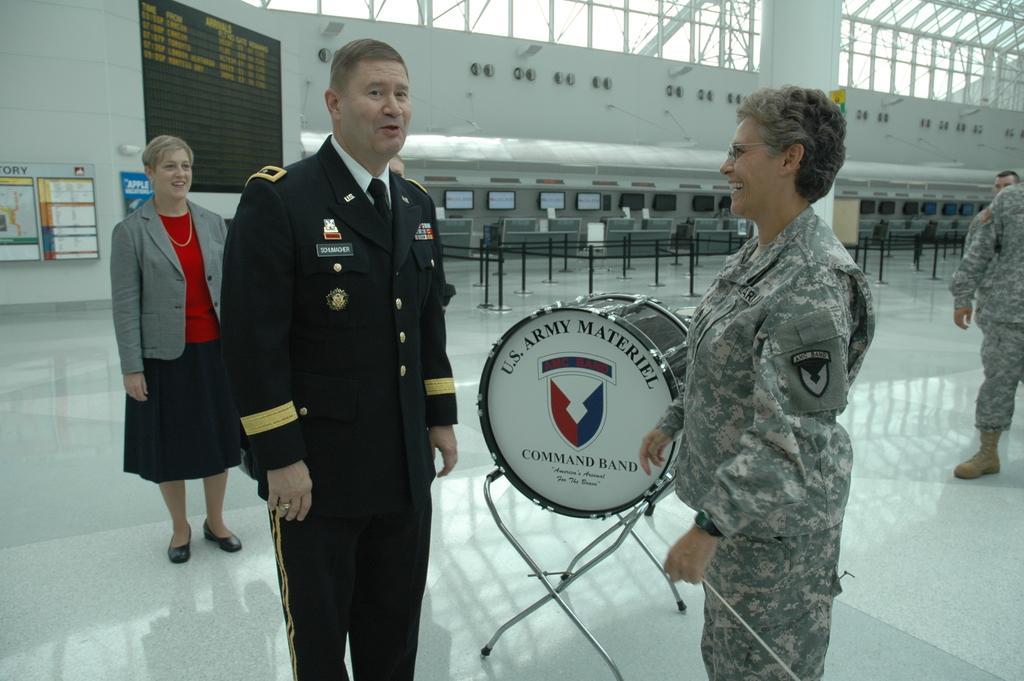How would you summarize this image in a sentence or two? On the left side, there is a woman in red color T-shirt, smiling and standing. Beside her, there is a person in an uniform, standing and speaking. Beside this person, there is a drum arranged on the floor. On the right side, there is a person in an uniform, smiling and standing. In the background, there are two persons, there is a pillar, there are posters attached to the wall, there are fences and there is a white wall. 